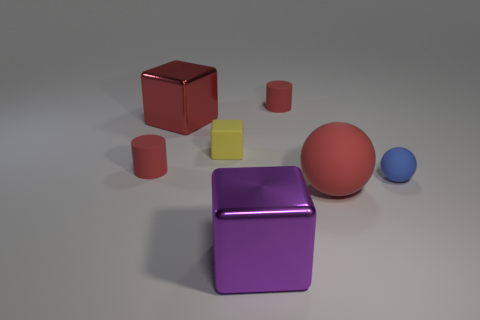How many small red cylinders are to the left of the small cylinder behind the small rubber cylinder on the left side of the tiny block?
Provide a short and direct response. 1. There is a purple metal cube; are there any yellow rubber things in front of it?
Give a very brief answer. No. What number of other objects are the same size as the yellow matte block?
Your response must be concise. 3. What material is the object that is both in front of the red cube and left of the yellow rubber block?
Offer a very short reply. Rubber. Does the big red thing that is in front of the red block have the same shape as the object to the right of the large rubber sphere?
Make the answer very short. Yes. What shape is the tiny red matte thing that is behind the large thing that is to the left of the big shiny object in front of the small blue thing?
Offer a very short reply. Cylinder. How many other objects are there of the same shape as the purple shiny thing?
Give a very brief answer. 2. There is a sphere that is the same size as the yellow matte cube; what is its color?
Offer a terse response. Blue. How many cubes are either small red things or big rubber objects?
Offer a terse response. 0. How many matte blocks are there?
Make the answer very short. 1. 